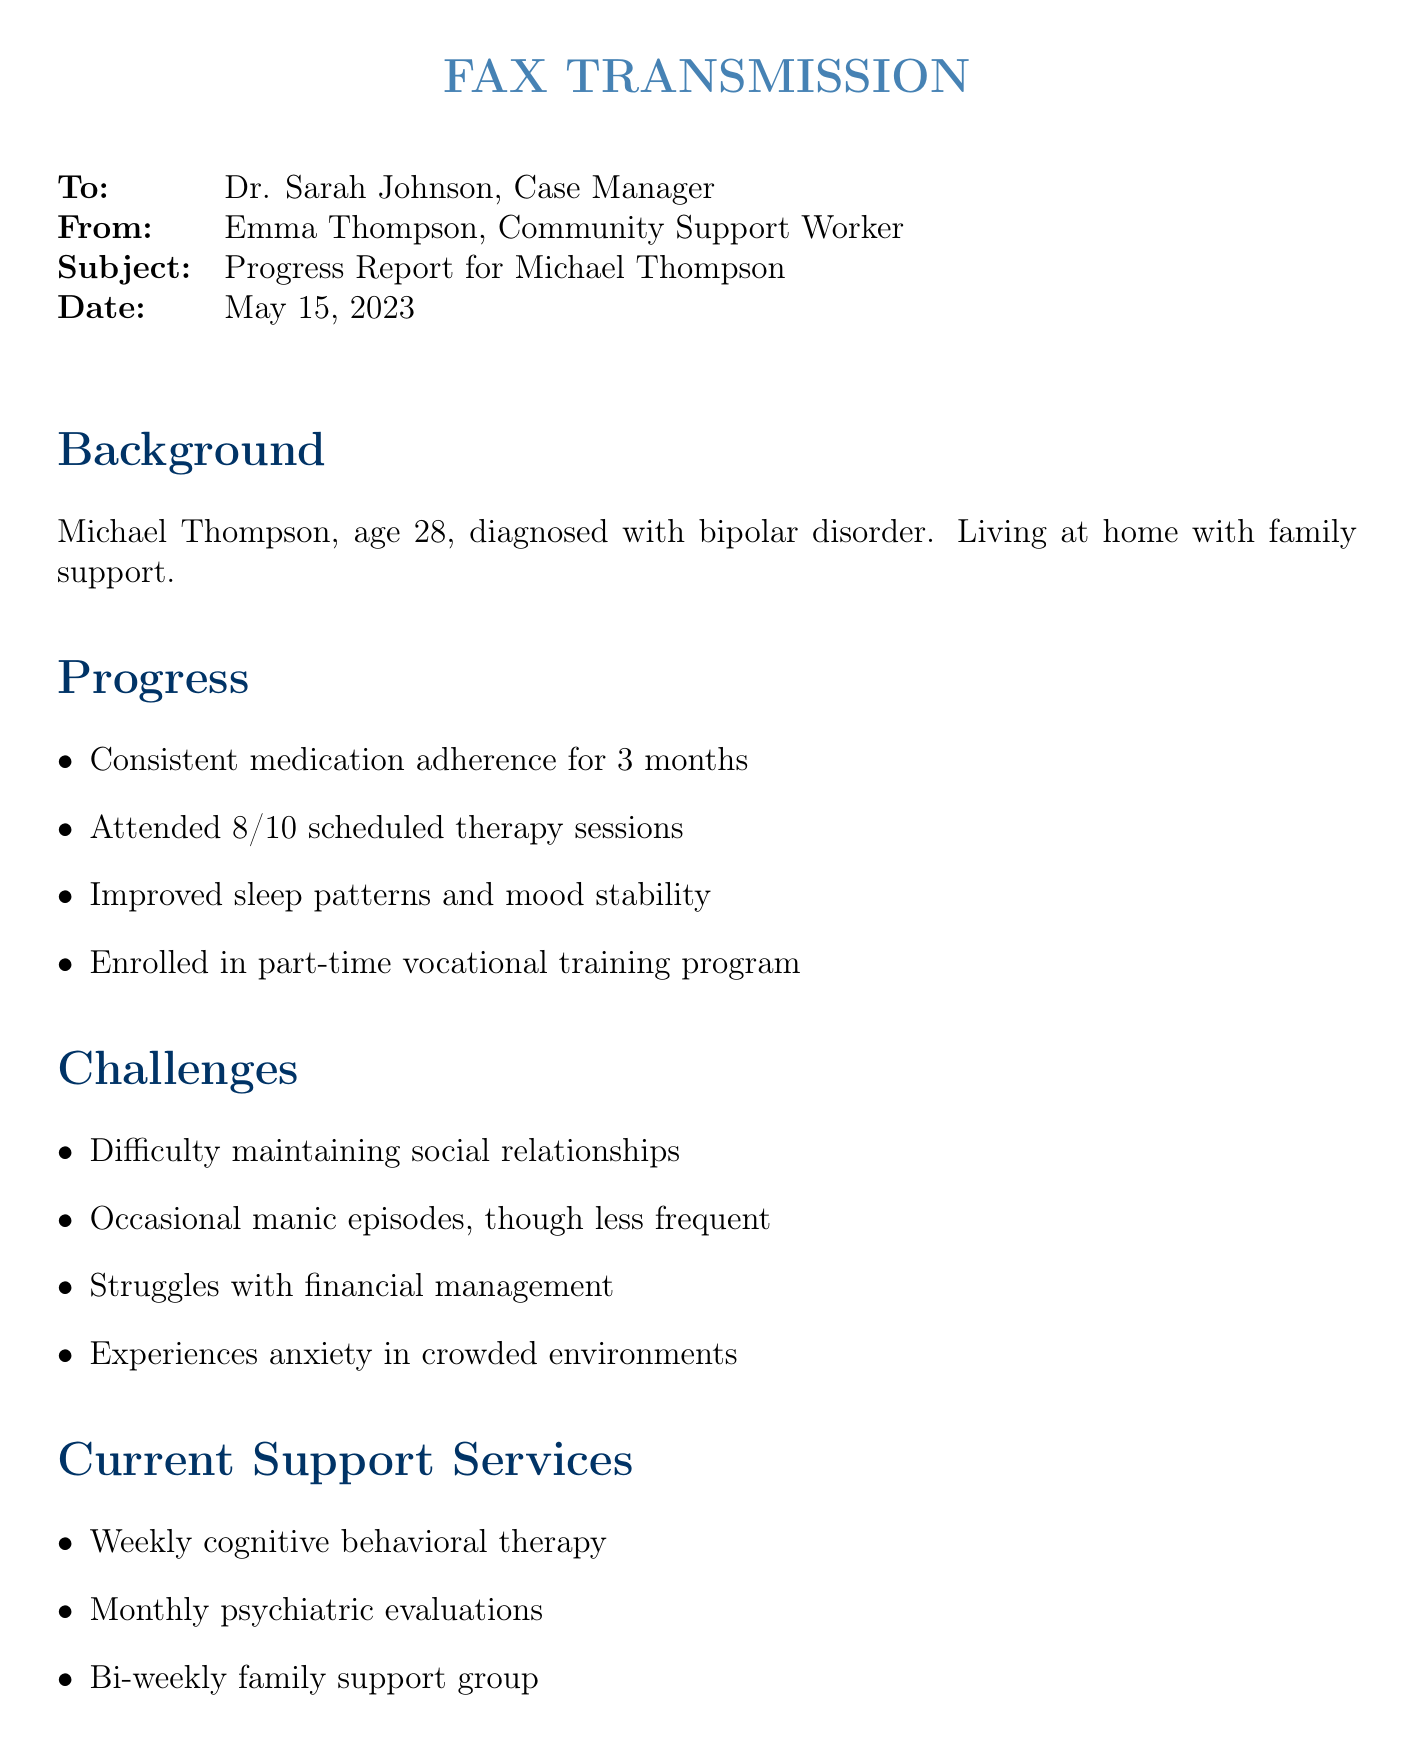What is the name of the individual being reported on? The document identifies the individual as Michael Thompson.
Answer: Michael Thompson What is Michael's age? The document states that Michael Thompson is 28 years old.
Answer: 28 How many therapy sessions did Michael attend? The document indicates that Michael attended 8 out of 10 scheduled therapy sessions.
Answer: 8/10 What is one of the challenges mentioned? The document lists several challenges, one being difficulty maintaining social relationships.
Answer: Difficulty maintaining social relationships When was the fax transmitted? The document specifies the date of the transmission as May 15, 2023.
Answer: May 15, 2023 What recommendation is made regarding employment? The document recommends exploring supported employment options.
Answer: Supported employment options How often does Michael receive psychiatric evaluations? The document states that psychiatric evaluations occur monthly.
Answer: Monthly Who is the case manager receiving the fax? The document identifies the case manager as Dr. Sarah Johnson.
Answer: Dr. Sarah Johnson What type of therapy does Michael attend weekly? The document indicates that Michael participates in weekly cognitive behavioral therapy.
Answer: Cognitive behavioral therapy 